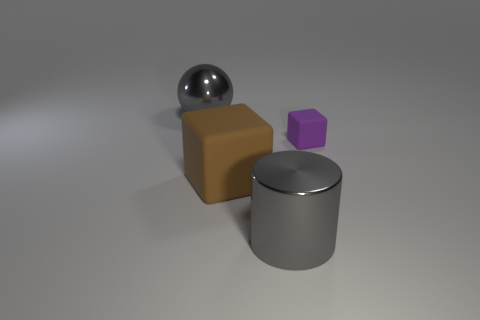Add 1 gray balls. How many objects exist? 5 Subtract all cylinders. How many objects are left? 3 Subtract all shiny cylinders. Subtract all tiny red shiny cylinders. How many objects are left? 3 Add 1 brown blocks. How many brown blocks are left? 2 Add 4 purple objects. How many purple objects exist? 5 Subtract 0 cyan cylinders. How many objects are left? 4 